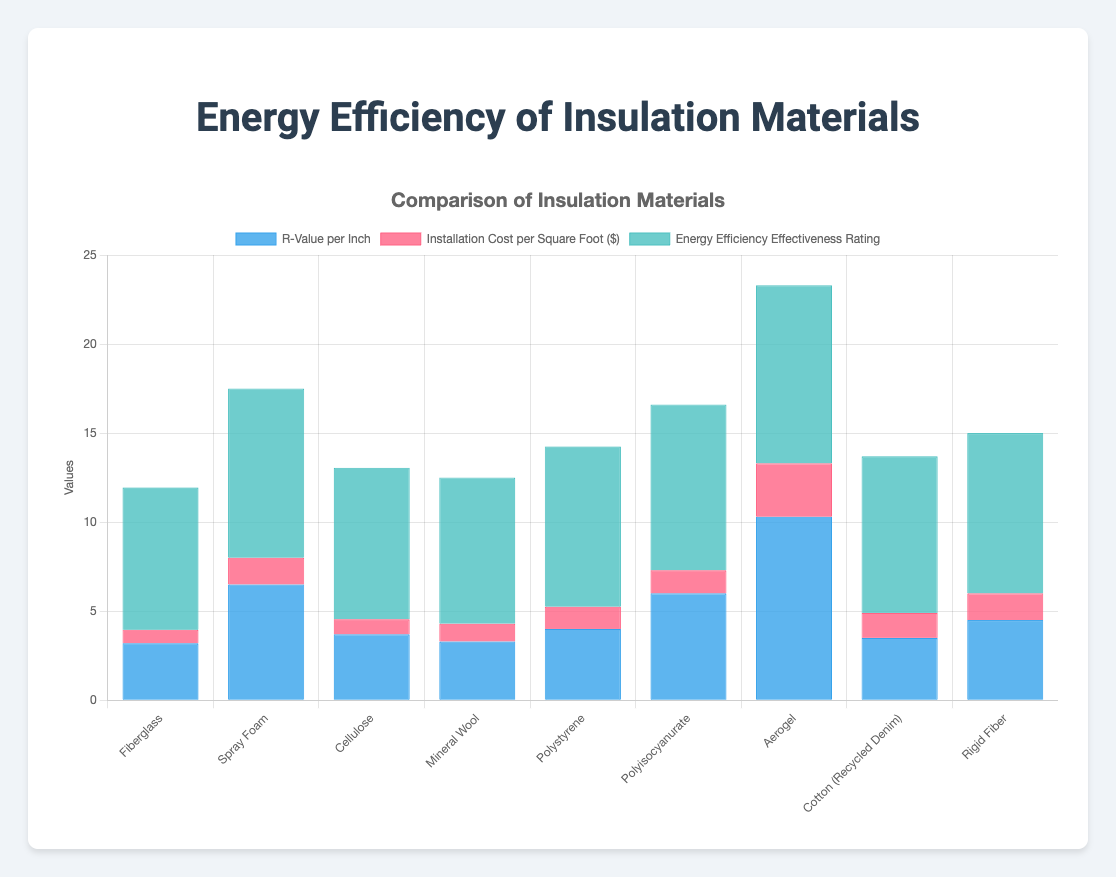Which insulation material has the highest R-Value per Inch? The material with the highest R-Value per Inch can be identified by looking for the tallest blue bar in the chart. Aerogel has the highest R-Value per Inch of 10.3.
Answer: Aerogel Which materials have an Energy Efficiency Effectiveness Rating of 9.0 and above? Identify the materials with green bars at or above the 9.0 mark on the y-axis. Spray Foam, Polystyrene, Polyisocyanurate, Aerogel, and Rigid Fiber meet this criterion.
Answer: Spray Foam, Polystyrene, Polyisocyanurate, Aerogel, Rigid Fiber What is the installation cost difference between Spray Foam and Mineral Wool per square foot? Look at the red bars for Spray Foam and Mineral Wool and calculate the difference between their heights. Spray Foam costs $1.50, and Mineral Wool costs $1.00, making the difference $0.50.
Answer: $0.50 Which insulation material provides the best balance of cost and energy efficiency? To determine this, compare the height of the red and green bars. Aerogel, although the most efficient, has a high cost. Polyisocyanurate and Rigid Fiber both offer high efficiency (green bar) and have relatively moderate installation costs (red bar).
Answer: Polyisocyanurate, Rigid Fiber Calculate the average R-Value per Inch for the given materials. Sum the R-Values of all materials and divide by the number of materials: (3.2 + 6.5 + 3.7 + 3.3 + 4.0 + 6.0 + 10.3 + 3.5 + 4.5) / 9 = 5.0.
Answer: 5.0 Which material has the lowest installation cost per square foot? Look for the shortest red bar in the chart. Fiberglass has the lowest installation cost of $0.75 per square foot.
Answer: Fiberglass How do the energy efficiency ratings of Cotton (Recycled Denim) and Cellulose compare? Check the height of the green bars for both materials. Cellulose has a rating of 8.5, and Cotton (Recycled Denim) has a rating of 8.8, so Cotton (Recycled Denim) is slightly more efficient.
Answer: Cotton (Recycled Denim) is more efficient How much higher is Aerogel's R-Value per Inch compared to Fiberglass? Subtract Fiberglass's R-Value from Aerogel's R-Value: 10.3 - 3.2 = 7.1.
Answer: 7.1 Which material has the second-highest installation cost per square foot? After identifying the tallest red bar (Aerogel), look for the next tallest. Spray Foam and Rigid Fiber both have installation costs of $1.50 per square foot, making them the second highest.
Answer: Spray Foam, Rigid Fiber 